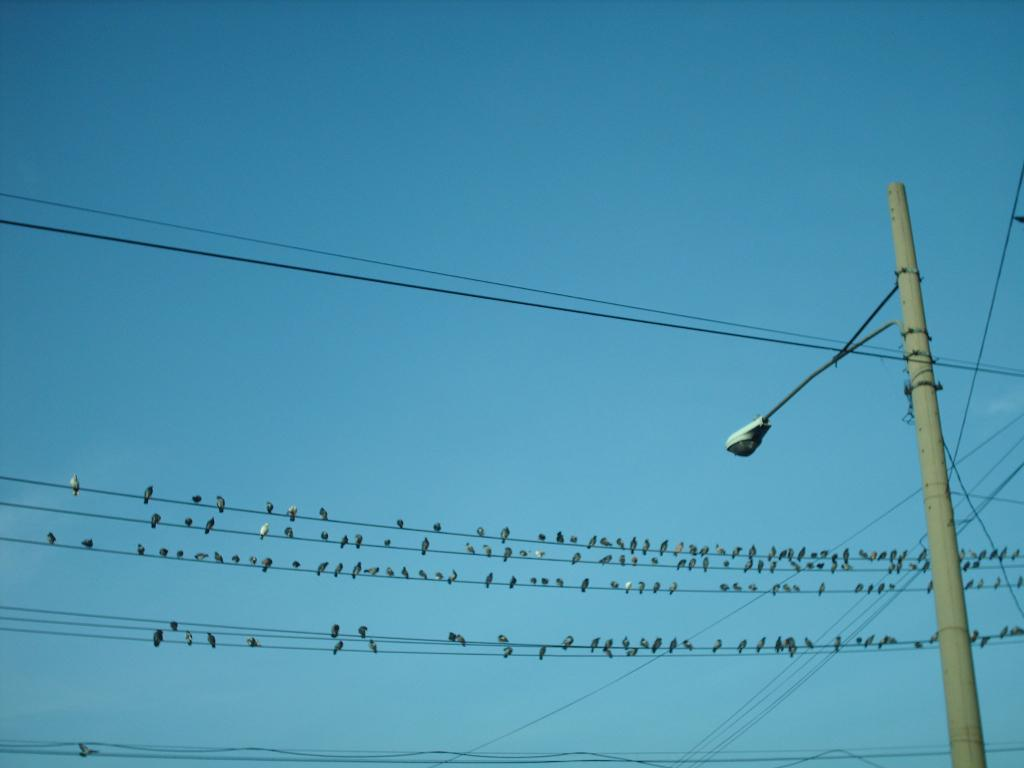What structure is located on the right side of the image? There is a light pole on the right side of the image. What else can be seen in the image besides the light pole? There are wires visible in the image, and birds are present on some of the wires. What is visible in the background of the image? The sky is clear and visible in the background of the image. What type of song is the crook singing in the image? There is no crook or song present in the image; it features a light pole, wires, birds, and a clear sky. 